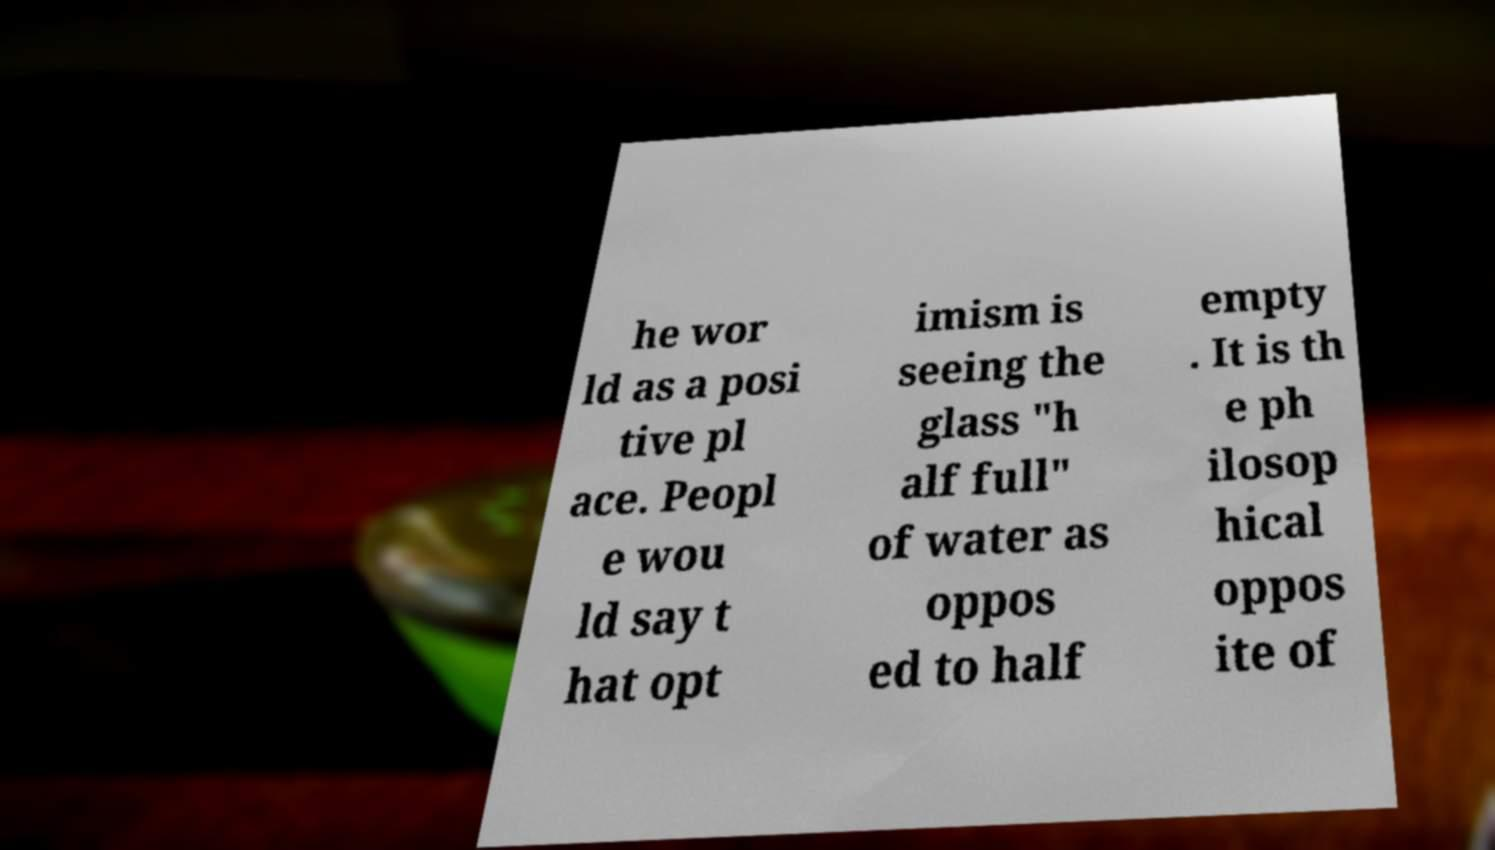Please identify and transcribe the text found in this image. he wor ld as a posi tive pl ace. Peopl e wou ld say t hat opt imism is seeing the glass "h alf full" of water as oppos ed to half empty . It is th e ph ilosop hical oppos ite of 